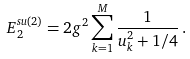<formula> <loc_0><loc_0><loc_500><loc_500>E _ { 2 } ^ { s u ( 2 ) } = 2 g ^ { 2 } \sum _ { k = 1 } ^ { M } \frac { 1 } { u _ { k } ^ { 2 } + 1 / 4 } \, .</formula> 